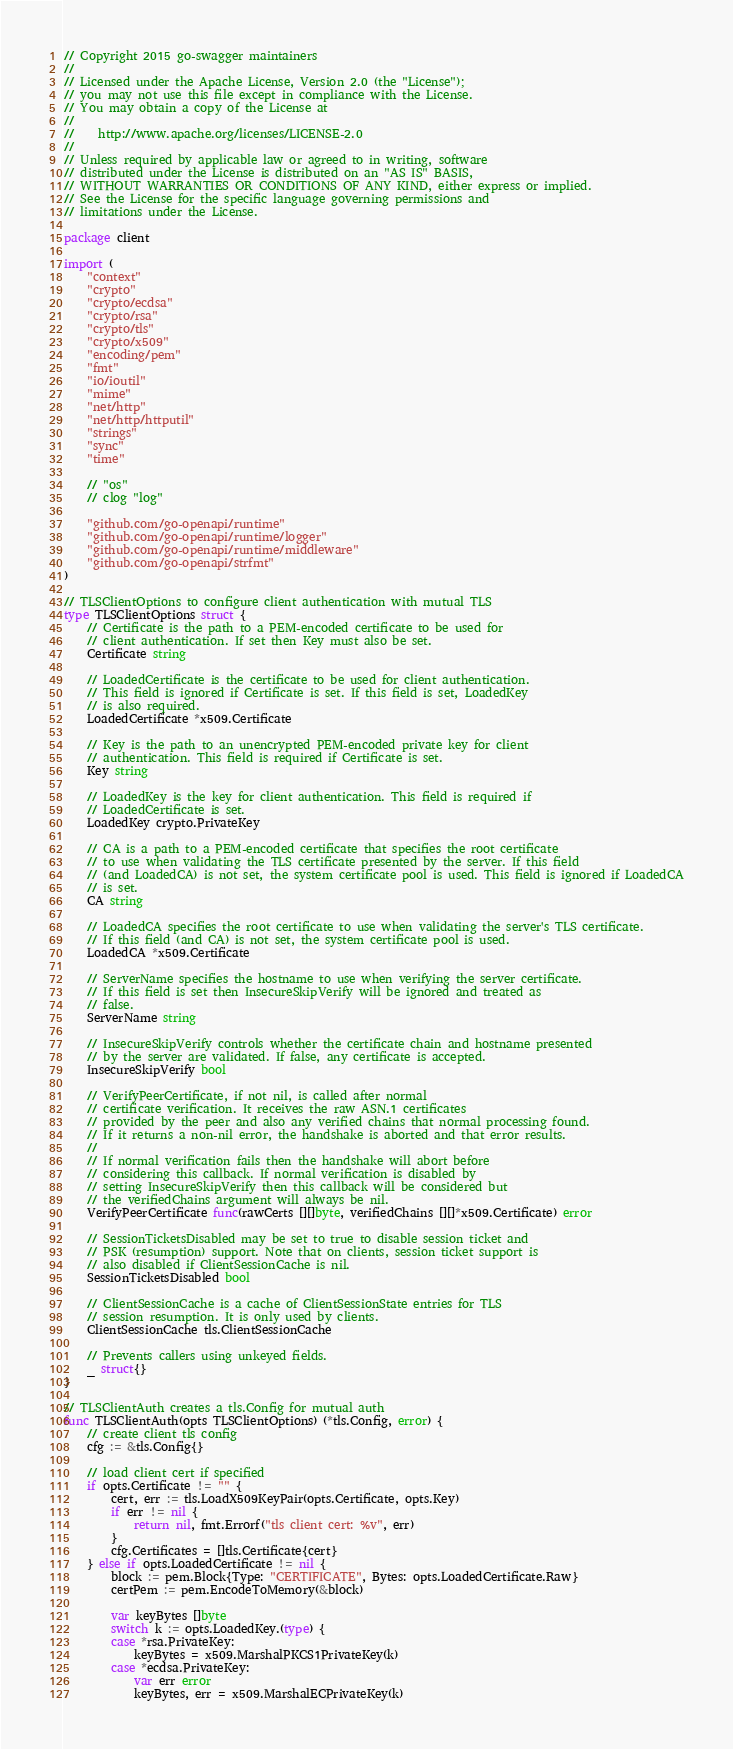<code> <loc_0><loc_0><loc_500><loc_500><_Go_>// Copyright 2015 go-swagger maintainers
//
// Licensed under the Apache License, Version 2.0 (the "License");
// you may not use this file except in compliance with the License.
// You may obtain a copy of the License at
//
//    http://www.apache.org/licenses/LICENSE-2.0
//
// Unless required by applicable law or agreed to in writing, software
// distributed under the License is distributed on an "AS IS" BASIS,
// WITHOUT WARRANTIES OR CONDITIONS OF ANY KIND, either express or implied.
// See the License for the specific language governing permissions and
// limitations under the License.

package client

import (
	"context"
	"crypto"
	"crypto/ecdsa"
	"crypto/rsa"
	"crypto/tls"
	"crypto/x509"
	"encoding/pem"
	"fmt"
	"io/ioutil"
	"mime"
	"net/http"
	"net/http/httputil"
	"strings"
	"sync"
	"time"

	// "os"
	// clog "log"

	"github.com/go-openapi/runtime"
	"github.com/go-openapi/runtime/logger"
	"github.com/go-openapi/runtime/middleware"
	"github.com/go-openapi/strfmt"
)

// TLSClientOptions to configure client authentication with mutual TLS
type TLSClientOptions struct {
	// Certificate is the path to a PEM-encoded certificate to be used for
	// client authentication. If set then Key must also be set.
	Certificate string

	// LoadedCertificate is the certificate to be used for client authentication.
	// This field is ignored if Certificate is set. If this field is set, LoadedKey
	// is also required.
	LoadedCertificate *x509.Certificate

	// Key is the path to an unencrypted PEM-encoded private key for client
	// authentication. This field is required if Certificate is set.
	Key string

	// LoadedKey is the key for client authentication. This field is required if
	// LoadedCertificate is set.
	LoadedKey crypto.PrivateKey

	// CA is a path to a PEM-encoded certificate that specifies the root certificate
	// to use when validating the TLS certificate presented by the server. If this field
	// (and LoadedCA) is not set, the system certificate pool is used. This field is ignored if LoadedCA
	// is set.
	CA string

	// LoadedCA specifies the root certificate to use when validating the server's TLS certificate.
	// If this field (and CA) is not set, the system certificate pool is used.
	LoadedCA *x509.Certificate

	// ServerName specifies the hostname to use when verifying the server certificate.
	// If this field is set then InsecureSkipVerify will be ignored and treated as
	// false.
	ServerName string

	// InsecureSkipVerify controls whether the certificate chain and hostname presented
	// by the server are validated. If false, any certificate is accepted.
	InsecureSkipVerify bool

	// VerifyPeerCertificate, if not nil, is called after normal
	// certificate verification. It receives the raw ASN.1 certificates
	// provided by the peer and also any verified chains that normal processing found.
	// If it returns a non-nil error, the handshake is aborted and that error results.
	//
	// If normal verification fails then the handshake will abort before
	// considering this callback. If normal verification is disabled by
	// setting InsecureSkipVerify then this callback will be considered but
	// the verifiedChains argument will always be nil.
	VerifyPeerCertificate func(rawCerts [][]byte, verifiedChains [][]*x509.Certificate) error

	// SessionTicketsDisabled may be set to true to disable session ticket and
	// PSK (resumption) support. Note that on clients, session ticket support is
	// also disabled if ClientSessionCache is nil.
	SessionTicketsDisabled bool

	// ClientSessionCache is a cache of ClientSessionState entries for TLS
	// session resumption. It is only used by clients.
	ClientSessionCache tls.ClientSessionCache

	// Prevents callers using unkeyed fields.
	_ struct{}
}

// TLSClientAuth creates a tls.Config for mutual auth
func TLSClientAuth(opts TLSClientOptions) (*tls.Config, error) {
	// create client tls config
	cfg := &tls.Config{}

	// load client cert if specified
	if opts.Certificate != "" {
		cert, err := tls.LoadX509KeyPair(opts.Certificate, opts.Key)
		if err != nil {
			return nil, fmt.Errorf("tls client cert: %v", err)
		}
		cfg.Certificates = []tls.Certificate{cert}
	} else if opts.LoadedCertificate != nil {
		block := pem.Block{Type: "CERTIFICATE", Bytes: opts.LoadedCertificate.Raw}
		certPem := pem.EncodeToMemory(&block)

		var keyBytes []byte
		switch k := opts.LoadedKey.(type) {
		case *rsa.PrivateKey:
			keyBytes = x509.MarshalPKCS1PrivateKey(k)
		case *ecdsa.PrivateKey:
			var err error
			keyBytes, err = x509.MarshalECPrivateKey(k)</code> 